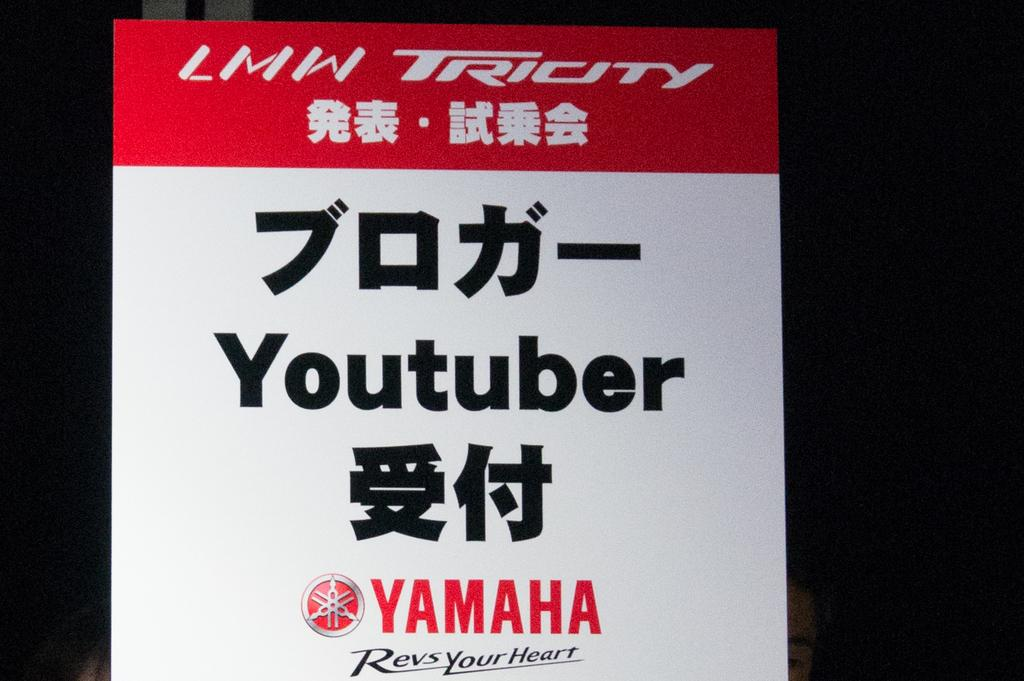<image>
Render a clear and concise summary of the photo. At the bottom of the sign it says Yamaha Revs Your Heart. 